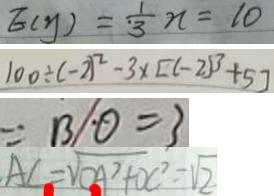<formula> <loc_0><loc_0><loc_500><loc_500>E ( y ) = \frac { 1 } { 3 } n = 1 0 
 1 0 0 \div ( - 2 ) ^ { 2 } - 3 \times [ ( - 2 ) ^ { 3 } + 5 ] 
 = B O = 3 
 A C = \sqrt { O A ^ { 2 } + D C ^ { 2 } } = \sqrt { 2 }</formula> 